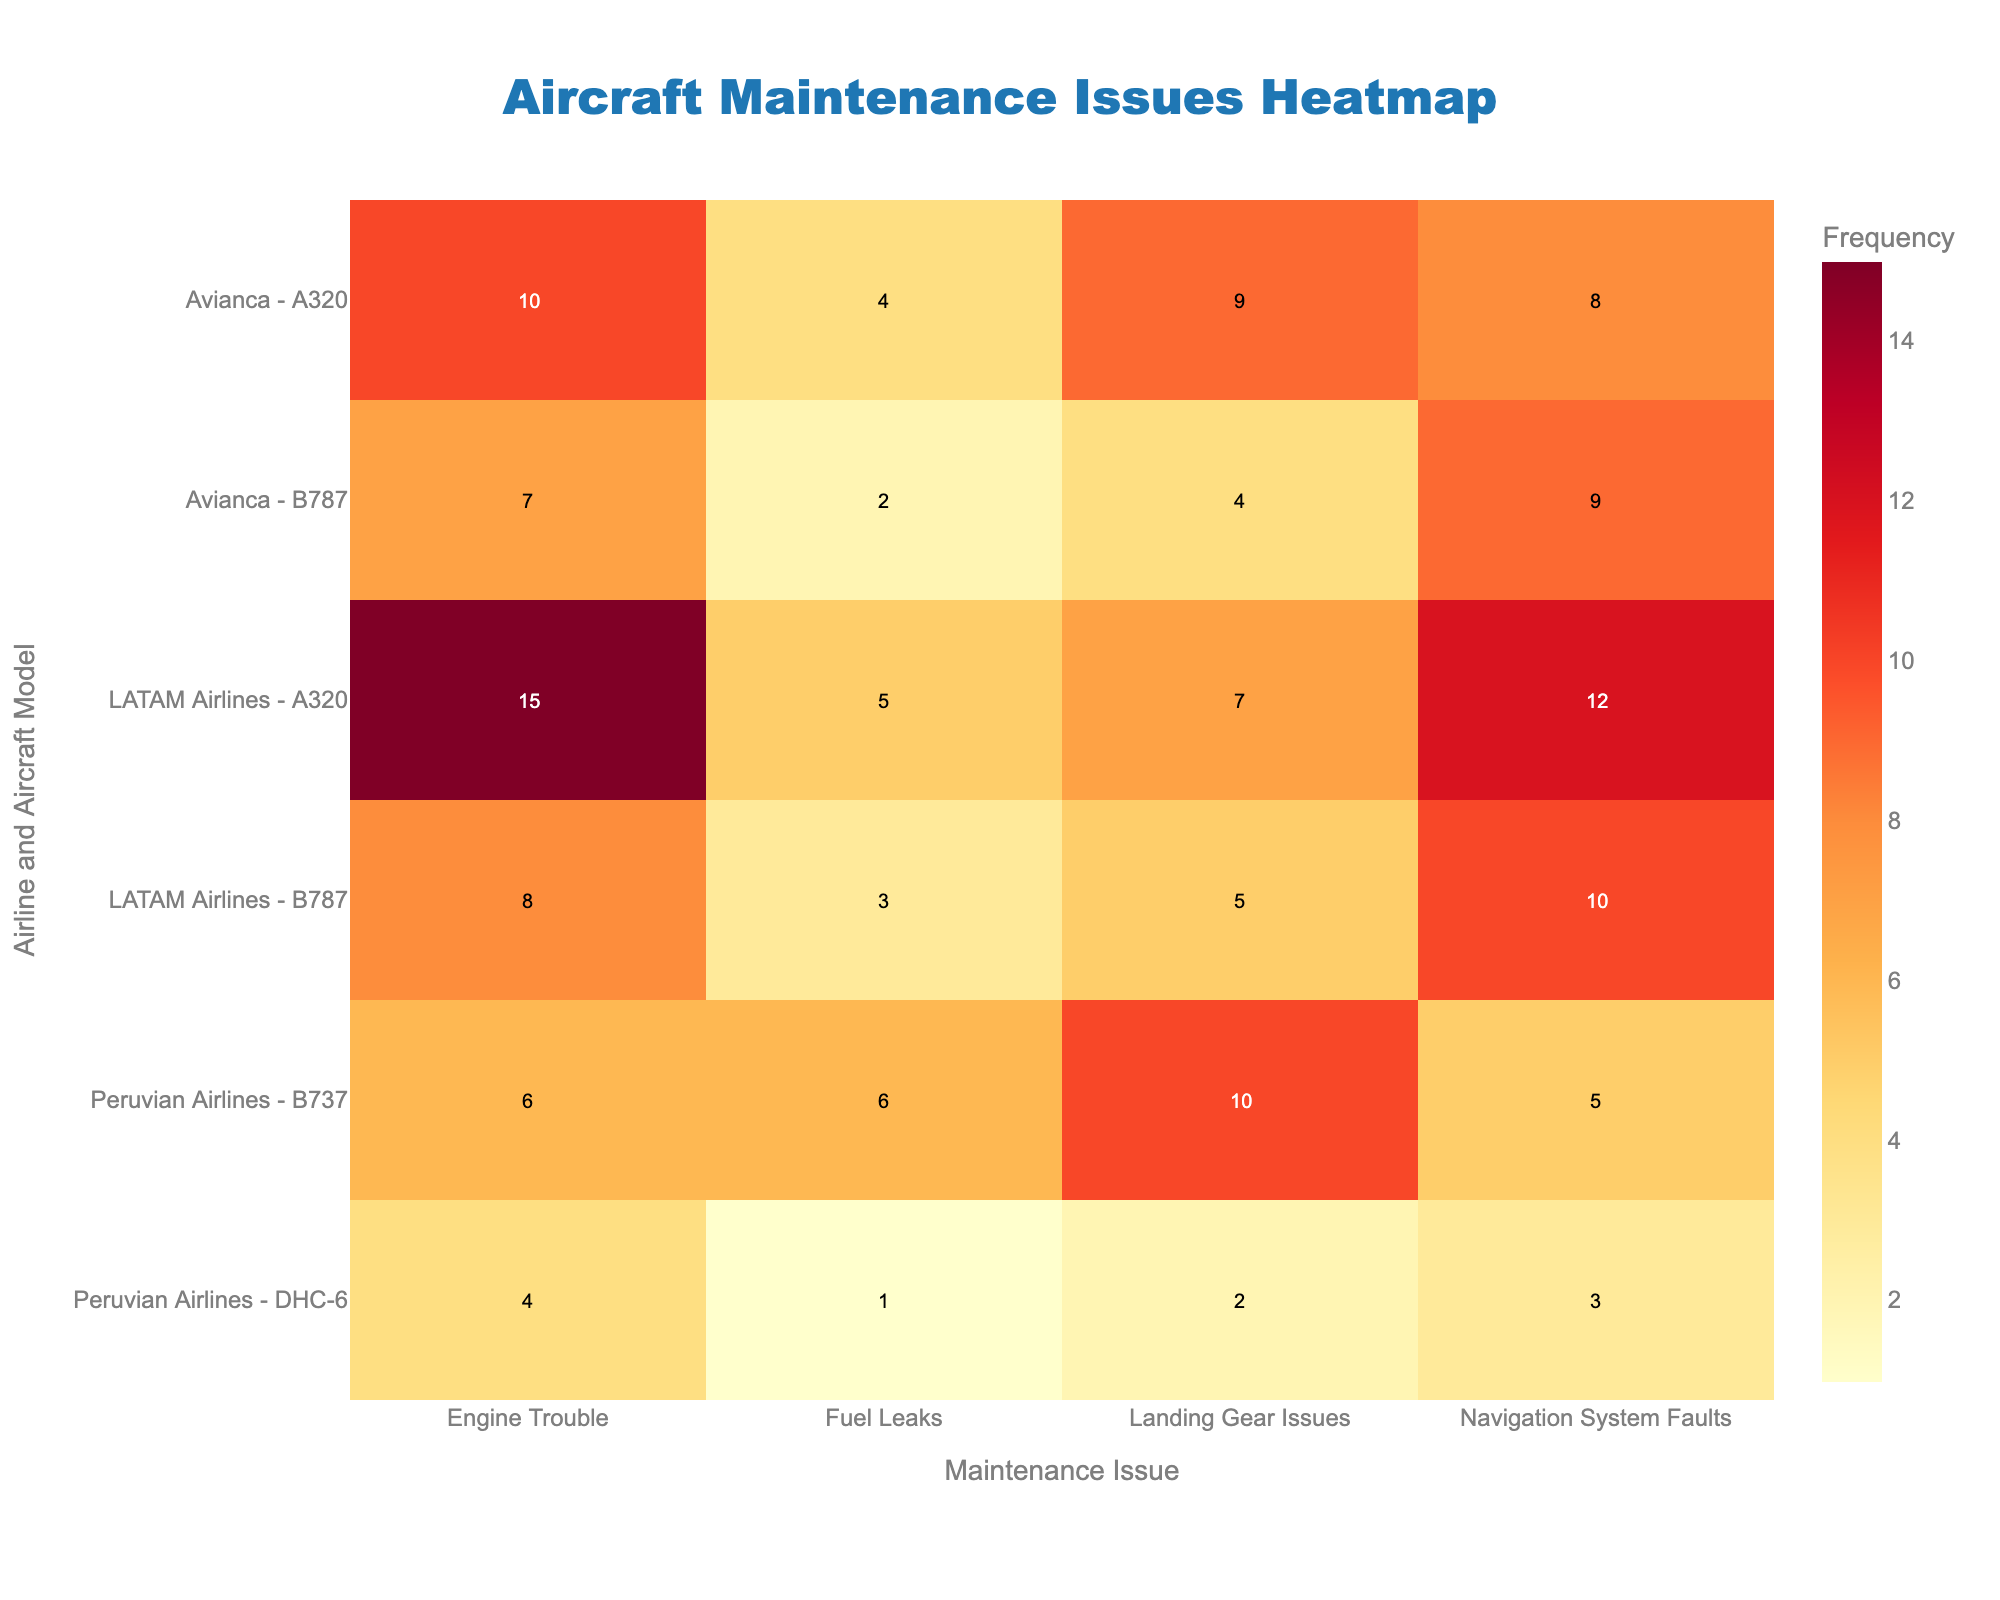What's the title of the heatmap? The title is located at the top of the heatmap in large, distinct font, making it easy to identify.
Answer: Aircraft Maintenance Issues Heatmap Which airline and aircraft model combination has the highest frequency of engine trouble? By scanning through the cells corresponding to "Engine Trouble," identify the cell with the highest number, which is 15, next to "LATAM Airlines - A320."
Answer: LATAM Airlines - A320 What is the total frequency of maintenance issues for LATAM Airlines' A320? Sum all frequencies for LATAM Airlines' A320 across all maintenance issues: 15 (Engine Trouble) + 12 (Navigation System Faults) + 7 (Landing Gear Issues) + 5 (Fuel Leaks) = 39.
Answer: 39 Compare the frequency of landing gear issues between Avianca's A320 and LATAM Airlines' A320. Which has more issues? Look at the values for "Landing Gear Issues" for both aircraft models. Avianca's A320 has 9, while LATAM Airlines' A320 has 7. Therefore, Avianca's A320 has more.
Answer: Avianca's A320 Which airline and aircraft model have the lowest frequency of any maintenance issue? Identify the cell with the lowest frequency number, which is 1, next to "Peruvian Airlines - DHC-6" for "Fuel Leaks."
Answer: Peruvian Airlines - DHC-6 What is the frequency range of navigation system faults across all airline and model combinations? Locate the highest and lowest values for "Navigation System Faults." The highest is 12 (LATAM Airlines - A320), and the lowest is 3 (Peruvian Airlines - DHC-6), so the range is 12 - 3 = 9.
Answer: 9 How does the frequency of fuel leaks for Peruvian Airlines' B737 compare to LATAM Airlines' B787? Peruvian Airlines' B737 has 6 fuel leaks, while LATAM Airlines' B787 has 3 fuel leaks. Peruvian Airlines' B737 has more fuel leaks.
Answer: Peruvian Airlines' B737 What is the overall frequency of maintenance issues reported by Avianca? Sum the frequencies for both Avianca models across all issues: (10 + 8 + 9 + 4) for A320 and (7 + 9 + 4 + 2) for B787. Total = 31 (A320) + 22 (B787) = 53.
Answer: 53 What's the average frequency of engine trouble across all aircraft models? Calculate the sum and average of the "Engine Trouble" frequencies: (15 + 8 + 10 + 7 + 6 + 4) / 6 = 50 / 6 ≈ 8.33.
Answer: ~8.33 Which maintenance issue has the highest total frequency across all airlines and aircraft models? Sum the frequencies for each maintenance issue and compare. Engine Trouble: 50, Navigation System Faults: 47, Landing Gear Issues: 37, Fuel Leaks: 21. Engine Trouble has the highest frequency.
Answer: Engine Trouble 